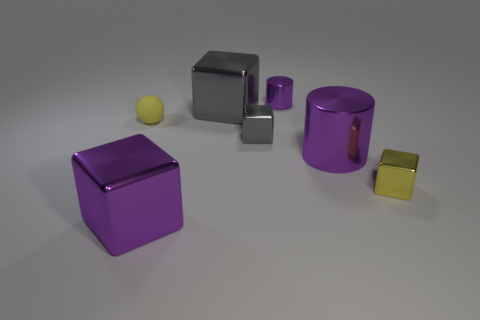There is a large block that is the same color as the tiny shiny cylinder; what is it made of?
Your response must be concise. Metal. What is the size of the metallic cube that is the same color as the sphere?
Your response must be concise. Small. There is a big object in front of the small yellow block; does it have the same color as the small cube on the right side of the large purple shiny cylinder?
Ensure brevity in your answer.  No. How many things are either big purple cubes or purple cylinders?
Provide a short and direct response. 3. What number of other objects are there of the same shape as the big gray object?
Make the answer very short. 3. Are the yellow thing to the left of the purple cube and the big purple object to the right of the purple block made of the same material?
Offer a very short reply. No. The shiny object that is to the left of the small yellow cube and on the right side of the small purple metallic cylinder has what shape?
Give a very brief answer. Cylinder. Are there any other things that have the same material as the small cylinder?
Offer a very short reply. Yes. The thing that is behind the tiny yellow metal cube and right of the small purple shiny cylinder is made of what material?
Provide a short and direct response. Metal. There is a small purple object that is the same material as the tiny yellow block; what shape is it?
Provide a succinct answer. Cylinder. 